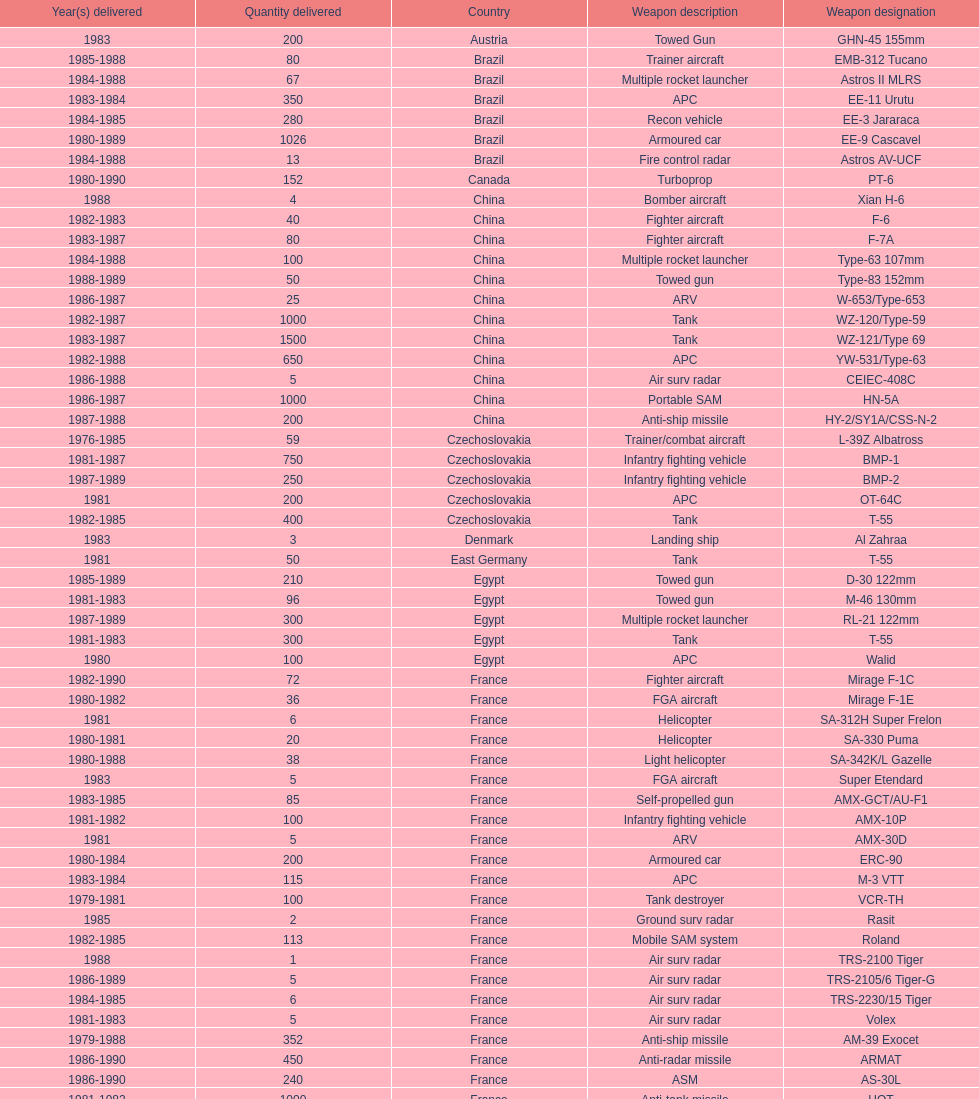Which country had the largest number of towed guns delivered? Soviet Union. 